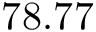<formula> <loc_0><loc_0><loc_500><loc_500>7 8 . 7 7</formula> 